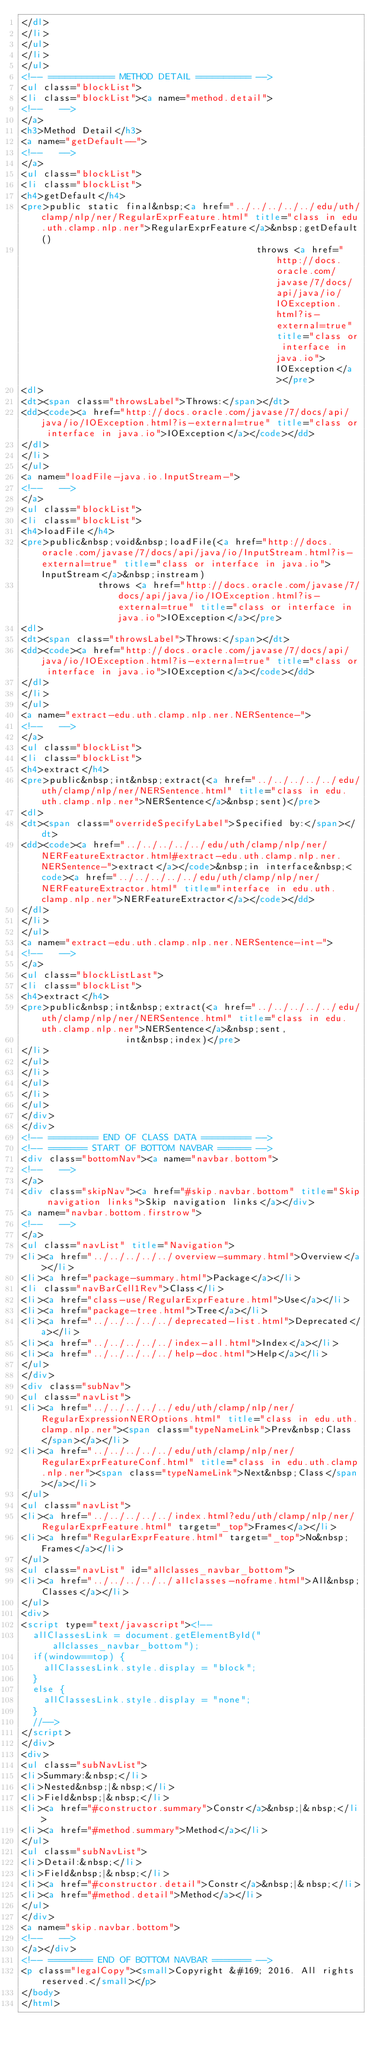<code> <loc_0><loc_0><loc_500><loc_500><_HTML_></dl>
</li>
</ul>
</li>
</ul>
<!-- ============ METHOD DETAIL ========== -->
<ul class="blockList">
<li class="blockList"><a name="method.detail">
<!--   -->
</a>
<h3>Method Detail</h3>
<a name="getDefault--">
<!--   -->
</a>
<ul class="blockList">
<li class="blockList">
<h4>getDefault</h4>
<pre>public static final&nbsp;<a href="../../../../../edu/uth/clamp/nlp/ner/RegularExprFeature.html" title="class in edu.uth.clamp.nlp.ner">RegularExprFeature</a>&nbsp;getDefault()
                                           throws <a href="http://docs.oracle.com/javase/7/docs/api/java/io/IOException.html?is-external=true" title="class or interface in java.io">IOException</a></pre>
<dl>
<dt><span class="throwsLabel">Throws:</span></dt>
<dd><code><a href="http://docs.oracle.com/javase/7/docs/api/java/io/IOException.html?is-external=true" title="class or interface in java.io">IOException</a></code></dd>
</dl>
</li>
</ul>
<a name="loadFile-java.io.InputStream-">
<!--   -->
</a>
<ul class="blockList">
<li class="blockList">
<h4>loadFile</h4>
<pre>public&nbsp;void&nbsp;loadFile(<a href="http://docs.oracle.com/javase/7/docs/api/java/io/InputStream.html?is-external=true" title="class or interface in java.io">InputStream</a>&nbsp;instream)
              throws <a href="http://docs.oracle.com/javase/7/docs/api/java/io/IOException.html?is-external=true" title="class or interface in java.io">IOException</a></pre>
<dl>
<dt><span class="throwsLabel">Throws:</span></dt>
<dd><code><a href="http://docs.oracle.com/javase/7/docs/api/java/io/IOException.html?is-external=true" title="class or interface in java.io">IOException</a></code></dd>
</dl>
</li>
</ul>
<a name="extract-edu.uth.clamp.nlp.ner.NERSentence-">
<!--   -->
</a>
<ul class="blockList">
<li class="blockList">
<h4>extract</h4>
<pre>public&nbsp;int&nbsp;extract(<a href="../../../../../edu/uth/clamp/nlp/ner/NERSentence.html" title="class in edu.uth.clamp.nlp.ner">NERSentence</a>&nbsp;sent)</pre>
<dl>
<dt><span class="overrideSpecifyLabel">Specified by:</span></dt>
<dd><code><a href="../../../../../edu/uth/clamp/nlp/ner/NERFeatureExtractor.html#extract-edu.uth.clamp.nlp.ner.NERSentence-">extract</a></code>&nbsp;in interface&nbsp;<code><a href="../../../../../edu/uth/clamp/nlp/ner/NERFeatureExtractor.html" title="interface in edu.uth.clamp.nlp.ner">NERFeatureExtractor</a></code></dd>
</dl>
</li>
</ul>
<a name="extract-edu.uth.clamp.nlp.ner.NERSentence-int-">
<!--   -->
</a>
<ul class="blockListLast">
<li class="blockList">
<h4>extract</h4>
<pre>public&nbsp;int&nbsp;extract(<a href="../../../../../edu/uth/clamp/nlp/ner/NERSentence.html" title="class in edu.uth.clamp.nlp.ner">NERSentence</a>&nbsp;sent,
                   int&nbsp;index)</pre>
</li>
</ul>
</li>
</ul>
</li>
</ul>
</div>
</div>
<!-- ========= END OF CLASS DATA ========= -->
<!-- ======= START OF BOTTOM NAVBAR ====== -->
<div class="bottomNav"><a name="navbar.bottom">
<!--   -->
</a>
<div class="skipNav"><a href="#skip.navbar.bottom" title="Skip navigation links">Skip navigation links</a></div>
<a name="navbar.bottom.firstrow">
<!--   -->
</a>
<ul class="navList" title="Navigation">
<li><a href="../../../../../overview-summary.html">Overview</a></li>
<li><a href="package-summary.html">Package</a></li>
<li class="navBarCell1Rev">Class</li>
<li><a href="class-use/RegularExprFeature.html">Use</a></li>
<li><a href="package-tree.html">Tree</a></li>
<li><a href="../../../../../deprecated-list.html">Deprecated</a></li>
<li><a href="../../../../../index-all.html">Index</a></li>
<li><a href="../../../../../help-doc.html">Help</a></li>
</ul>
</div>
<div class="subNav">
<ul class="navList">
<li><a href="../../../../../edu/uth/clamp/nlp/ner/RegularExpressionNEROptions.html" title="class in edu.uth.clamp.nlp.ner"><span class="typeNameLink">Prev&nbsp;Class</span></a></li>
<li><a href="../../../../../edu/uth/clamp/nlp/ner/RegularExprFeatureConf.html" title="class in edu.uth.clamp.nlp.ner"><span class="typeNameLink">Next&nbsp;Class</span></a></li>
</ul>
<ul class="navList">
<li><a href="../../../../../index.html?edu/uth/clamp/nlp/ner/RegularExprFeature.html" target="_top">Frames</a></li>
<li><a href="RegularExprFeature.html" target="_top">No&nbsp;Frames</a></li>
</ul>
<ul class="navList" id="allclasses_navbar_bottom">
<li><a href="../../../../../allclasses-noframe.html">All&nbsp;Classes</a></li>
</ul>
<div>
<script type="text/javascript"><!--
  allClassesLink = document.getElementById("allclasses_navbar_bottom");
  if(window==top) {
    allClassesLink.style.display = "block";
  }
  else {
    allClassesLink.style.display = "none";
  }
  //-->
</script>
</div>
<div>
<ul class="subNavList">
<li>Summary:&nbsp;</li>
<li>Nested&nbsp;|&nbsp;</li>
<li>Field&nbsp;|&nbsp;</li>
<li><a href="#constructor.summary">Constr</a>&nbsp;|&nbsp;</li>
<li><a href="#method.summary">Method</a></li>
</ul>
<ul class="subNavList">
<li>Detail:&nbsp;</li>
<li>Field&nbsp;|&nbsp;</li>
<li><a href="#constructor.detail">Constr</a>&nbsp;|&nbsp;</li>
<li><a href="#method.detail">Method</a></li>
</ul>
</div>
<a name="skip.navbar.bottom">
<!--   -->
</a></div>
<!-- ======== END OF BOTTOM NAVBAR ======= -->
<p class="legalCopy"><small>Copyright &#169; 2016. All rights reserved.</small></p>
</body>
</html>
</code> 